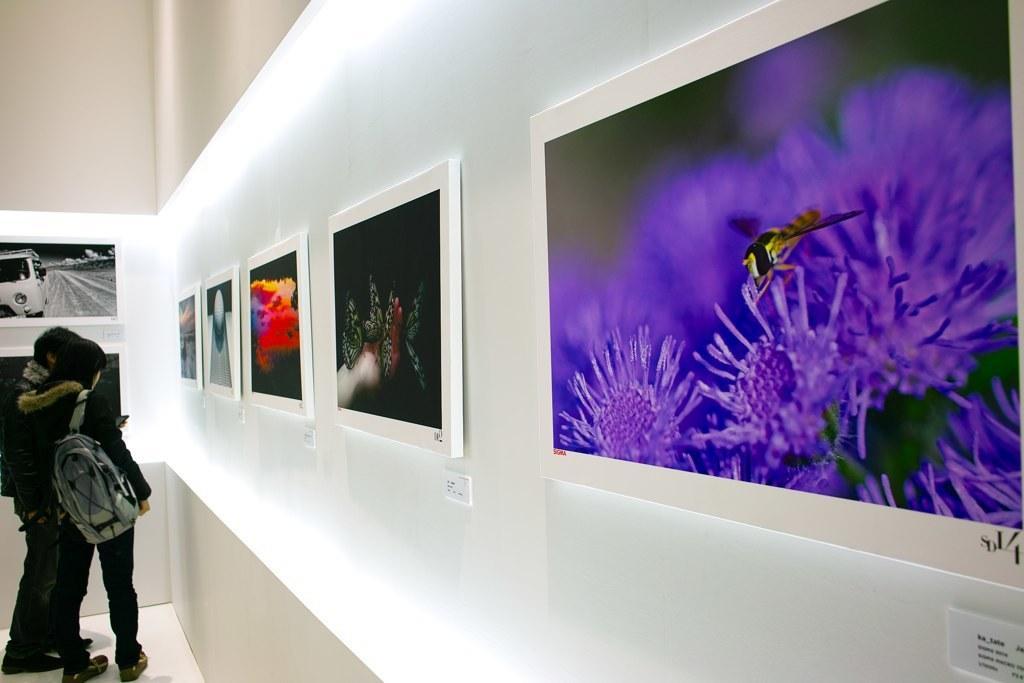Please provide a concise description of this image. In this picture we can see 2 people looking at the pictures in an art gallery. 